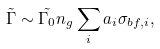<formula> <loc_0><loc_0><loc_500><loc_500>\tilde { \Gamma } \sim \tilde { \Gamma _ { 0 } } n _ { g } \sum _ { i } a _ { i } \sigma _ { b f , i } ,</formula> 